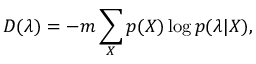Convert formula to latex. <formula><loc_0><loc_0><loc_500><loc_500>D ( \lambda ) = - m \sum _ { X } p ( X ) \log p ( \lambda | X ) ,</formula> 